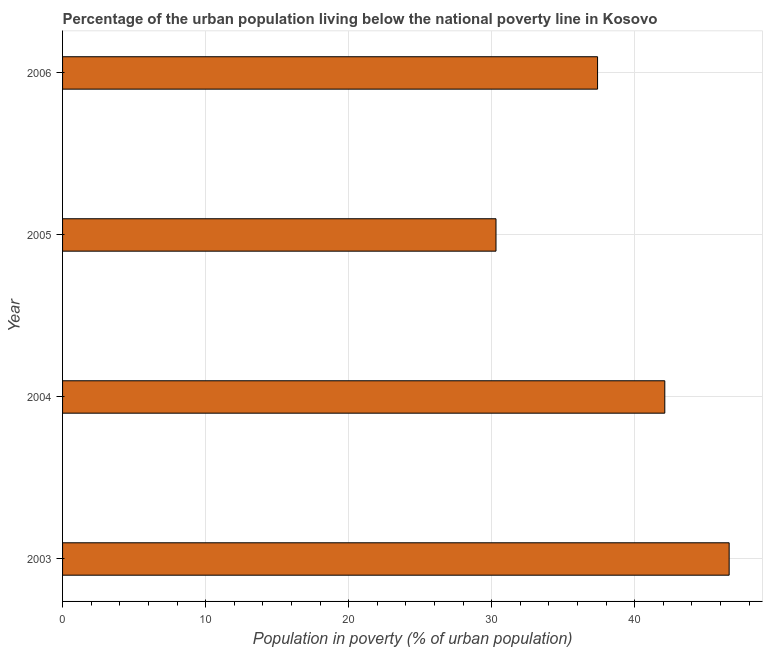Does the graph contain any zero values?
Make the answer very short. No. Does the graph contain grids?
Provide a short and direct response. Yes. What is the title of the graph?
Keep it short and to the point. Percentage of the urban population living below the national poverty line in Kosovo. What is the label or title of the X-axis?
Offer a very short reply. Population in poverty (% of urban population). What is the label or title of the Y-axis?
Offer a terse response. Year. What is the percentage of urban population living below poverty line in 2004?
Give a very brief answer. 42.1. Across all years, what is the maximum percentage of urban population living below poverty line?
Your answer should be very brief. 46.6. Across all years, what is the minimum percentage of urban population living below poverty line?
Keep it short and to the point. 30.3. In which year was the percentage of urban population living below poverty line maximum?
Provide a short and direct response. 2003. What is the sum of the percentage of urban population living below poverty line?
Offer a terse response. 156.4. What is the difference between the percentage of urban population living below poverty line in 2004 and 2006?
Your answer should be very brief. 4.7. What is the average percentage of urban population living below poverty line per year?
Ensure brevity in your answer.  39.1. What is the median percentage of urban population living below poverty line?
Make the answer very short. 39.75. Do a majority of the years between 2003 and 2006 (inclusive) have percentage of urban population living below poverty line greater than 34 %?
Your answer should be compact. Yes. What is the ratio of the percentage of urban population living below poverty line in 2003 to that in 2004?
Keep it short and to the point. 1.11. Is the percentage of urban population living below poverty line in 2003 less than that in 2005?
Offer a terse response. No. Is the difference between the percentage of urban population living below poverty line in 2003 and 2006 greater than the difference between any two years?
Make the answer very short. No. Is the sum of the percentage of urban population living below poverty line in 2003 and 2004 greater than the maximum percentage of urban population living below poverty line across all years?
Your response must be concise. Yes. What is the difference between the highest and the lowest percentage of urban population living below poverty line?
Make the answer very short. 16.3. How many bars are there?
Give a very brief answer. 4. Are all the bars in the graph horizontal?
Offer a very short reply. Yes. How many years are there in the graph?
Provide a succinct answer. 4. What is the Population in poverty (% of urban population) of 2003?
Offer a very short reply. 46.6. What is the Population in poverty (% of urban population) in 2004?
Your answer should be compact. 42.1. What is the Population in poverty (% of urban population) in 2005?
Offer a very short reply. 30.3. What is the Population in poverty (% of urban population) in 2006?
Provide a short and direct response. 37.4. What is the ratio of the Population in poverty (% of urban population) in 2003 to that in 2004?
Offer a very short reply. 1.11. What is the ratio of the Population in poverty (% of urban population) in 2003 to that in 2005?
Your answer should be very brief. 1.54. What is the ratio of the Population in poverty (% of urban population) in 2003 to that in 2006?
Your answer should be compact. 1.25. What is the ratio of the Population in poverty (% of urban population) in 2004 to that in 2005?
Keep it short and to the point. 1.39. What is the ratio of the Population in poverty (% of urban population) in 2004 to that in 2006?
Provide a succinct answer. 1.13. What is the ratio of the Population in poverty (% of urban population) in 2005 to that in 2006?
Your response must be concise. 0.81. 